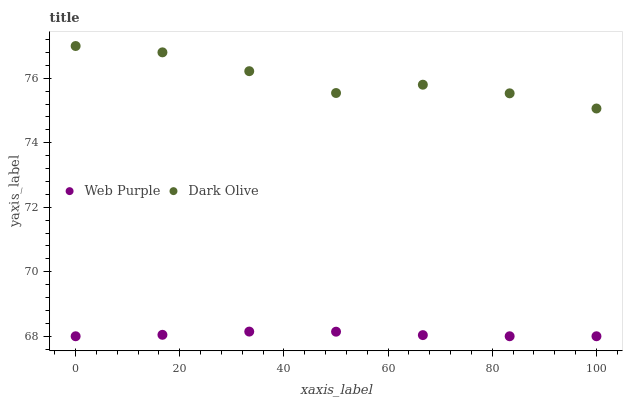Does Web Purple have the minimum area under the curve?
Answer yes or no. Yes. Does Dark Olive have the maximum area under the curve?
Answer yes or no. Yes. Does Dark Olive have the minimum area under the curve?
Answer yes or no. No. Is Web Purple the smoothest?
Answer yes or no. Yes. Is Dark Olive the roughest?
Answer yes or no. Yes. Is Dark Olive the smoothest?
Answer yes or no. No. Does Web Purple have the lowest value?
Answer yes or no. Yes. Does Dark Olive have the lowest value?
Answer yes or no. No. Does Dark Olive have the highest value?
Answer yes or no. Yes. Is Web Purple less than Dark Olive?
Answer yes or no. Yes. Is Dark Olive greater than Web Purple?
Answer yes or no. Yes. Does Web Purple intersect Dark Olive?
Answer yes or no. No. 